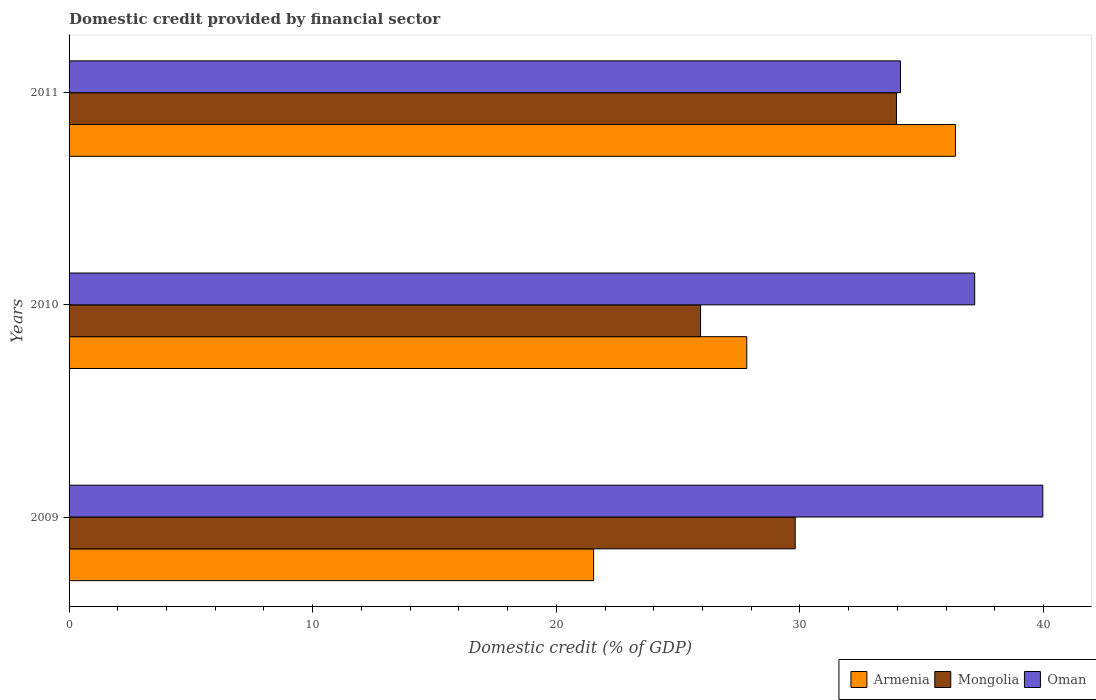Are the number of bars per tick equal to the number of legend labels?
Provide a short and direct response. Yes. How many bars are there on the 2nd tick from the bottom?
Provide a short and direct response. 3. What is the label of the 2nd group of bars from the top?
Provide a succinct answer. 2010. In how many cases, is the number of bars for a given year not equal to the number of legend labels?
Provide a succinct answer. 0. What is the domestic credit in Armenia in 2010?
Keep it short and to the point. 27.82. Across all years, what is the maximum domestic credit in Mongolia?
Offer a terse response. 33.96. Across all years, what is the minimum domestic credit in Armenia?
Provide a succinct answer. 21.53. What is the total domestic credit in Oman in the graph?
Your response must be concise. 111.26. What is the difference between the domestic credit in Armenia in 2009 and that in 2011?
Provide a succinct answer. -14.85. What is the difference between the domestic credit in Armenia in 2010 and the domestic credit in Mongolia in 2009?
Offer a very short reply. -1.99. What is the average domestic credit in Armenia per year?
Keep it short and to the point. 28.58. In the year 2009, what is the difference between the domestic credit in Mongolia and domestic credit in Armenia?
Give a very brief answer. 8.27. What is the ratio of the domestic credit in Armenia in 2009 to that in 2010?
Offer a terse response. 0.77. Is the domestic credit in Oman in 2009 less than that in 2010?
Offer a terse response. No. What is the difference between the highest and the second highest domestic credit in Mongolia?
Your answer should be compact. 4.16. What is the difference between the highest and the lowest domestic credit in Armenia?
Make the answer very short. 14.85. Is the sum of the domestic credit in Armenia in 2010 and 2011 greater than the maximum domestic credit in Oman across all years?
Your answer should be compact. Yes. What does the 1st bar from the top in 2009 represents?
Offer a very short reply. Oman. What does the 1st bar from the bottom in 2011 represents?
Keep it short and to the point. Armenia. Is it the case that in every year, the sum of the domestic credit in Armenia and domestic credit in Oman is greater than the domestic credit in Mongolia?
Your response must be concise. Yes. What is the difference between two consecutive major ticks on the X-axis?
Make the answer very short. 10. Does the graph contain grids?
Ensure brevity in your answer.  No. What is the title of the graph?
Offer a terse response. Domestic credit provided by financial sector. Does "Zambia" appear as one of the legend labels in the graph?
Your response must be concise. No. What is the label or title of the X-axis?
Offer a very short reply. Domestic credit (% of GDP). What is the label or title of the Y-axis?
Make the answer very short. Years. What is the Domestic credit (% of GDP) in Armenia in 2009?
Your answer should be compact. 21.53. What is the Domestic credit (% of GDP) of Mongolia in 2009?
Your response must be concise. 29.8. What is the Domestic credit (% of GDP) in Oman in 2009?
Your response must be concise. 39.97. What is the Domestic credit (% of GDP) in Armenia in 2010?
Your answer should be very brief. 27.82. What is the Domestic credit (% of GDP) in Mongolia in 2010?
Provide a succinct answer. 25.92. What is the Domestic credit (% of GDP) in Oman in 2010?
Your answer should be compact. 37.17. What is the Domestic credit (% of GDP) of Armenia in 2011?
Your answer should be very brief. 36.38. What is the Domestic credit (% of GDP) of Mongolia in 2011?
Your answer should be compact. 33.96. What is the Domestic credit (% of GDP) of Oman in 2011?
Your answer should be very brief. 34.13. Across all years, what is the maximum Domestic credit (% of GDP) of Armenia?
Your answer should be compact. 36.38. Across all years, what is the maximum Domestic credit (% of GDP) of Mongolia?
Give a very brief answer. 33.96. Across all years, what is the maximum Domestic credit (% of GDP) in Oman?
Your answer should be compact. 39.97. Across all years, what is the minimum Domestic credit (% of GDP) of Armenia?
Your answer should be compact. 21.53. Across all years, what is the minimum Domestic credit (% of GDP) in Mongolia?
Make the answer very short. 25.92. Across all years, what is the minimum Domestic credit (% of GDP) of Oman?
Your answer should be compact. 34.13. What is the total Domestic credit (% of GDP) of Armenia in the graph?
Provide a succinct answer. 85.73. What is the total Domestic credit (% of GDP) in Mongolia in the graph?
Ensure brevity in your answer.  89.68. What is the total Domestic credit (% of GDP) of Oman in the graph?
Keep it short and to the point. 111.26. What is the difference between the Domestic credit (% of GDP) of Armenia in 2009 and that in 2010?
Ensure brevity in your answer.  -6.29. What is the difference between the Domestic credit (% of GDP) of Mongolia in 2009 and that in 2010?
Your answer should be compact. 3.88. What is the difference between the Domestic credit (% of GDP) of Oman in 2009 and that in 2010?
Offer a terse response. 2.8. What is the difference between the Domestic credit (% of GDP) in Armenia in 2009 and that in 2011?
Make the answer very short. -14.85. What is the difference between the Domestic credit (% of GDP) in Mongolia in 2009 and that in 2011?
Your answer should be compact. -4.16. What is the difference between the Domestic credit (% of GDP) in Oman in 2009 and that in 2011?
Provide a short and direct response. 5.84. What is the difference between the Domestic credit (% of GDP) of Armenia in 2010 and that in 2011?
Ensure brevity in your answer.  -8.57. What is the difference between the Domestic credit (% of GDP) in Mongolia in 2010 and that in 2011?
Your answer should be compact. -8.04. What is the difference between the Domestic credit (% of GDP) in Oman in 2010 and that in 2011?
Provide a short and direct response. 3.05. What is the difference between the Domestic credit (% of GDP) of Armenia in 2009 and the Domestic credit (% of GDP) of Mongolia in 2010?
Provide a short and direct response. -4.39. What is the difference between the Domestic credit (% of GDP) of Armenia in 2009 and the Domestic credit (% of GDP) of Oman in 2010?
Provide a succinct answer. -15.64. What is the difference between the Domestic credit (% of GDP) of Mongolia in 2009 and the Domestic credit (% of GDP) of Oman in 2010?
Give a very brief answer. -7.37. What is the difference between the Domestic credit (% of GDP) in Armenia in 2009 and the Domestic credit (% of GDP) in Mongolia in 2011?
Keep it short and to the point. -12.43. What is the difference between the Domestic credit (% of GDP) in Armenia in 2009 and the Domestic credit (% of GDP) in Oman in 2011?
Your answer should be compact. -12.6. What is the difference between the Domestic credit (% of GDP) in Mongolia in 2009 and the Domestic credit (% of GDP) in Oman in 2011?
Make the answer very short. -4.32. What is the difference between the Domestic credit (% of GDP) of Armenia in 2010 and the Domestic credit (% of GDP) of Mongolia in 2011?
Ensure brevity in your answer.  -6.14. What is the difference between the Domestic credit (% of GDP) in Armenia in 2010 and the Domestic credit (% of GDP) in Oman in 2011?
Your answer should be very brief. -6.31. What is the difference between the Domestic credit (% of GDP) of Mongolia in 2010 and the Domestic credit (% of GDP) of Oman in 2011?
Offer a terse response. -8.21. What is the average Domestic credit (% of GDP) of Armenia per year?
Your answer should be compact. 28.58. What is the average Domestic credit (% of GDP) of Mongolia per year?
Make the answer very short. 29.89. What is the average Domestic credit (% of GDP) of Oman per year?
Offer a terse response. 37.09. In the year 2009, what is the difference between the Domestic credit (% of GDP) in Armenia and Domestic credit (% of GDP) in Mongolia?
Keep it short and to the point. -8.27. In the year 2009, what is the difference between the Domestic credit (% of GDP) of Armenia and Domestic credit (% of GDP) of Oman?
Keep it short and to the point. -18.44. In the year 2009, what is the difference between the Domestic credit (% of GDP) of Mongolia and Domestic credit (% of GDP) of Oman?
Keep it short and to the point. -10.16. In the year 2010, what is the difference between the Domestic credit (% of GDP) in Armenia and Domestic credit (% of GDP) in Mongolia?
Keep it short and to the point. 1.9. In the year 2010, what is the difference between the Domestic credit (% of GDP) of Armenia and Domestic credit (% of GDP) of Oman?
Ensure brevity in your answer.  -9.36. In the year 2010, what is the difference between the Domestic credit (% of GDP) of Mongolia and Domestic credit (% of GDP) of Oman?
Offer a very short reply. -11.25. In the year 2011, what is the difference between the Domestic credit (% of GDP) in Armenia and Domestic credit (% of GDP) in Mongolia?
Your answer should be very brief. 2.42. In the year 2011, what is the difference between the Domestic credit (% of GDP) of Armenia and Domestic credit (% of GDP) of Oman?
Your answer should be very brief. 2.26. In the year 2011, what is the difference between the Domestic credit (% of GDP) in Mongolia and Domestic credit (% of GDP) in Oman?
Provide a succinct answer. -0.17. What is the ratio of the Domestic credit (% of GDP) in Armenia in 2009 to that in 2010?
Keep it short and to the point. 0.77. What is the ratio of the Domestic credit (% of GDP) in Mongolia in 2009 to that in 2010?
Ensure brevity in your answer.  1.15. What is the ratio of the Domestic credit (% of GDP) of Oman in 2009 to that in 2010?
Your response must be concise. 1.08. What is the ratio of the Domestic credit (% of GDP) in Armenia in 2009 to that in 2011?
Give a very brief answer. 0.59. What is the ratio of the Domestic credit (% of GDP) in Mongolia in 2009 to that in 2011?
Ensure brevity in your answer.  0.88. What is the ratio of the Domestic credit (% of GDP) of Oman in 2009 to that in 2011?
Offer a terse response. 1.17. What is the ratio of the Domestic credit (% of GDP) of Armenia in 2010 to that in 2011?
Ensure brevity in your answer.  0.76. What is the ratio of the Domestic credit (% of GDP) of Mongolia in 2010 to that in 2011?
Your response must be concise. 0.76. What is the ratio of the Domestic credit (% of GDP) of Oman in 2010 to that in 2011?
Give a very brief answer. 1.09. What is the difference between the highest and the second highest Domestic credit (% of GDP) in Armenia?
Keep it short and to the point. 8.57. What is the difference between the highest and the second highest Domestic credit (% of GDP) of Mongolia?
Offer a terse response. 4.16. What is the difference between the highest and the second highest Domestic credit (% of GDP) in Oman?
Make the answer very short. 2.8. What is the difference between the highest and the lowest Domestic credit (% of GDP) of Armenia?
Provide a succinct answer. 14.85. What is the difference between the highest and the lowest Domestic credit (% of GDP) of Mongolia?
Provide a succinct answer. 8.04. What is the difference between the highest and the lowest Domestic credit (% of GDP) in Oman?
Provide a succinct answer. 5.84. 